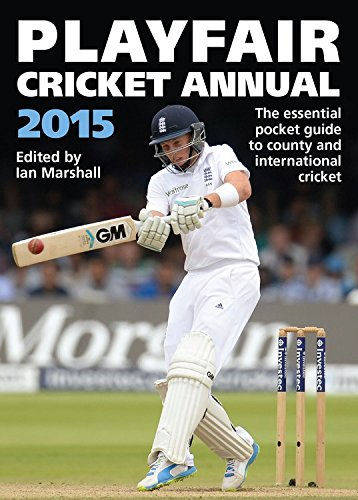What is the significance of the year mentioned on the book? The year 2015 on the book's title indicates that this edition covers the events, matches, and player statistics from the cricket season of that specific year, making it a valuable historical document for enthusiasts and analysts of the sport. 